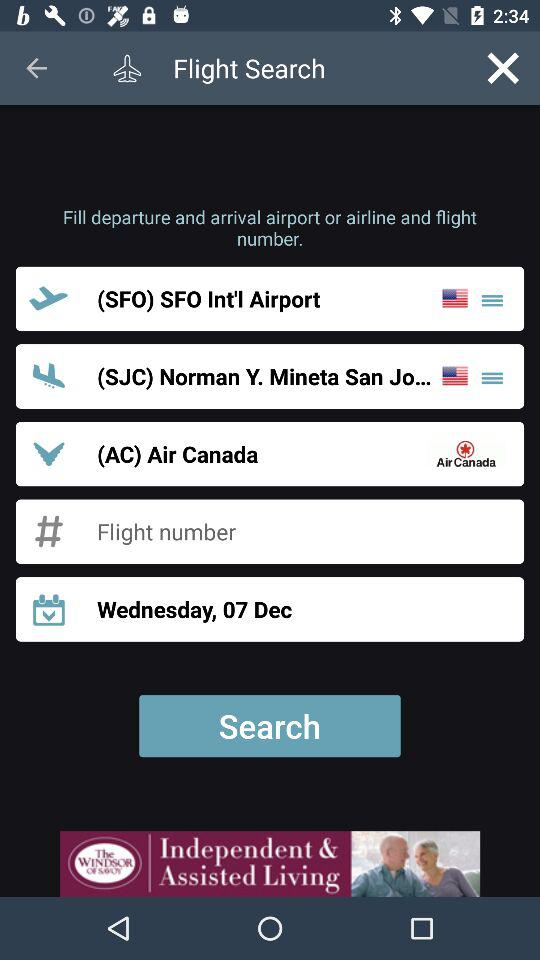On what day is the flight? The flight is on Wednesday. 